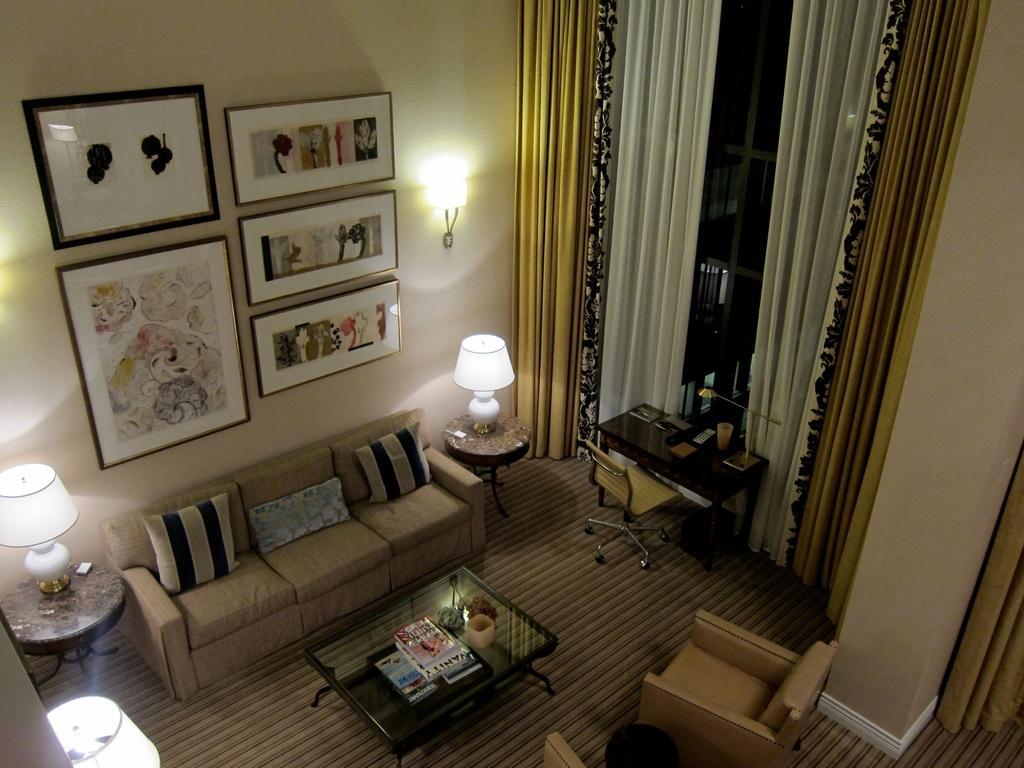Could you give a brief overview of what you see in this image? in the room there is a table in the center on which there are books. in its front and back there is a sofa. behind the sofa there is a sofa on which there are photo frames. at the right there is a table and a chair and curtains are present. 